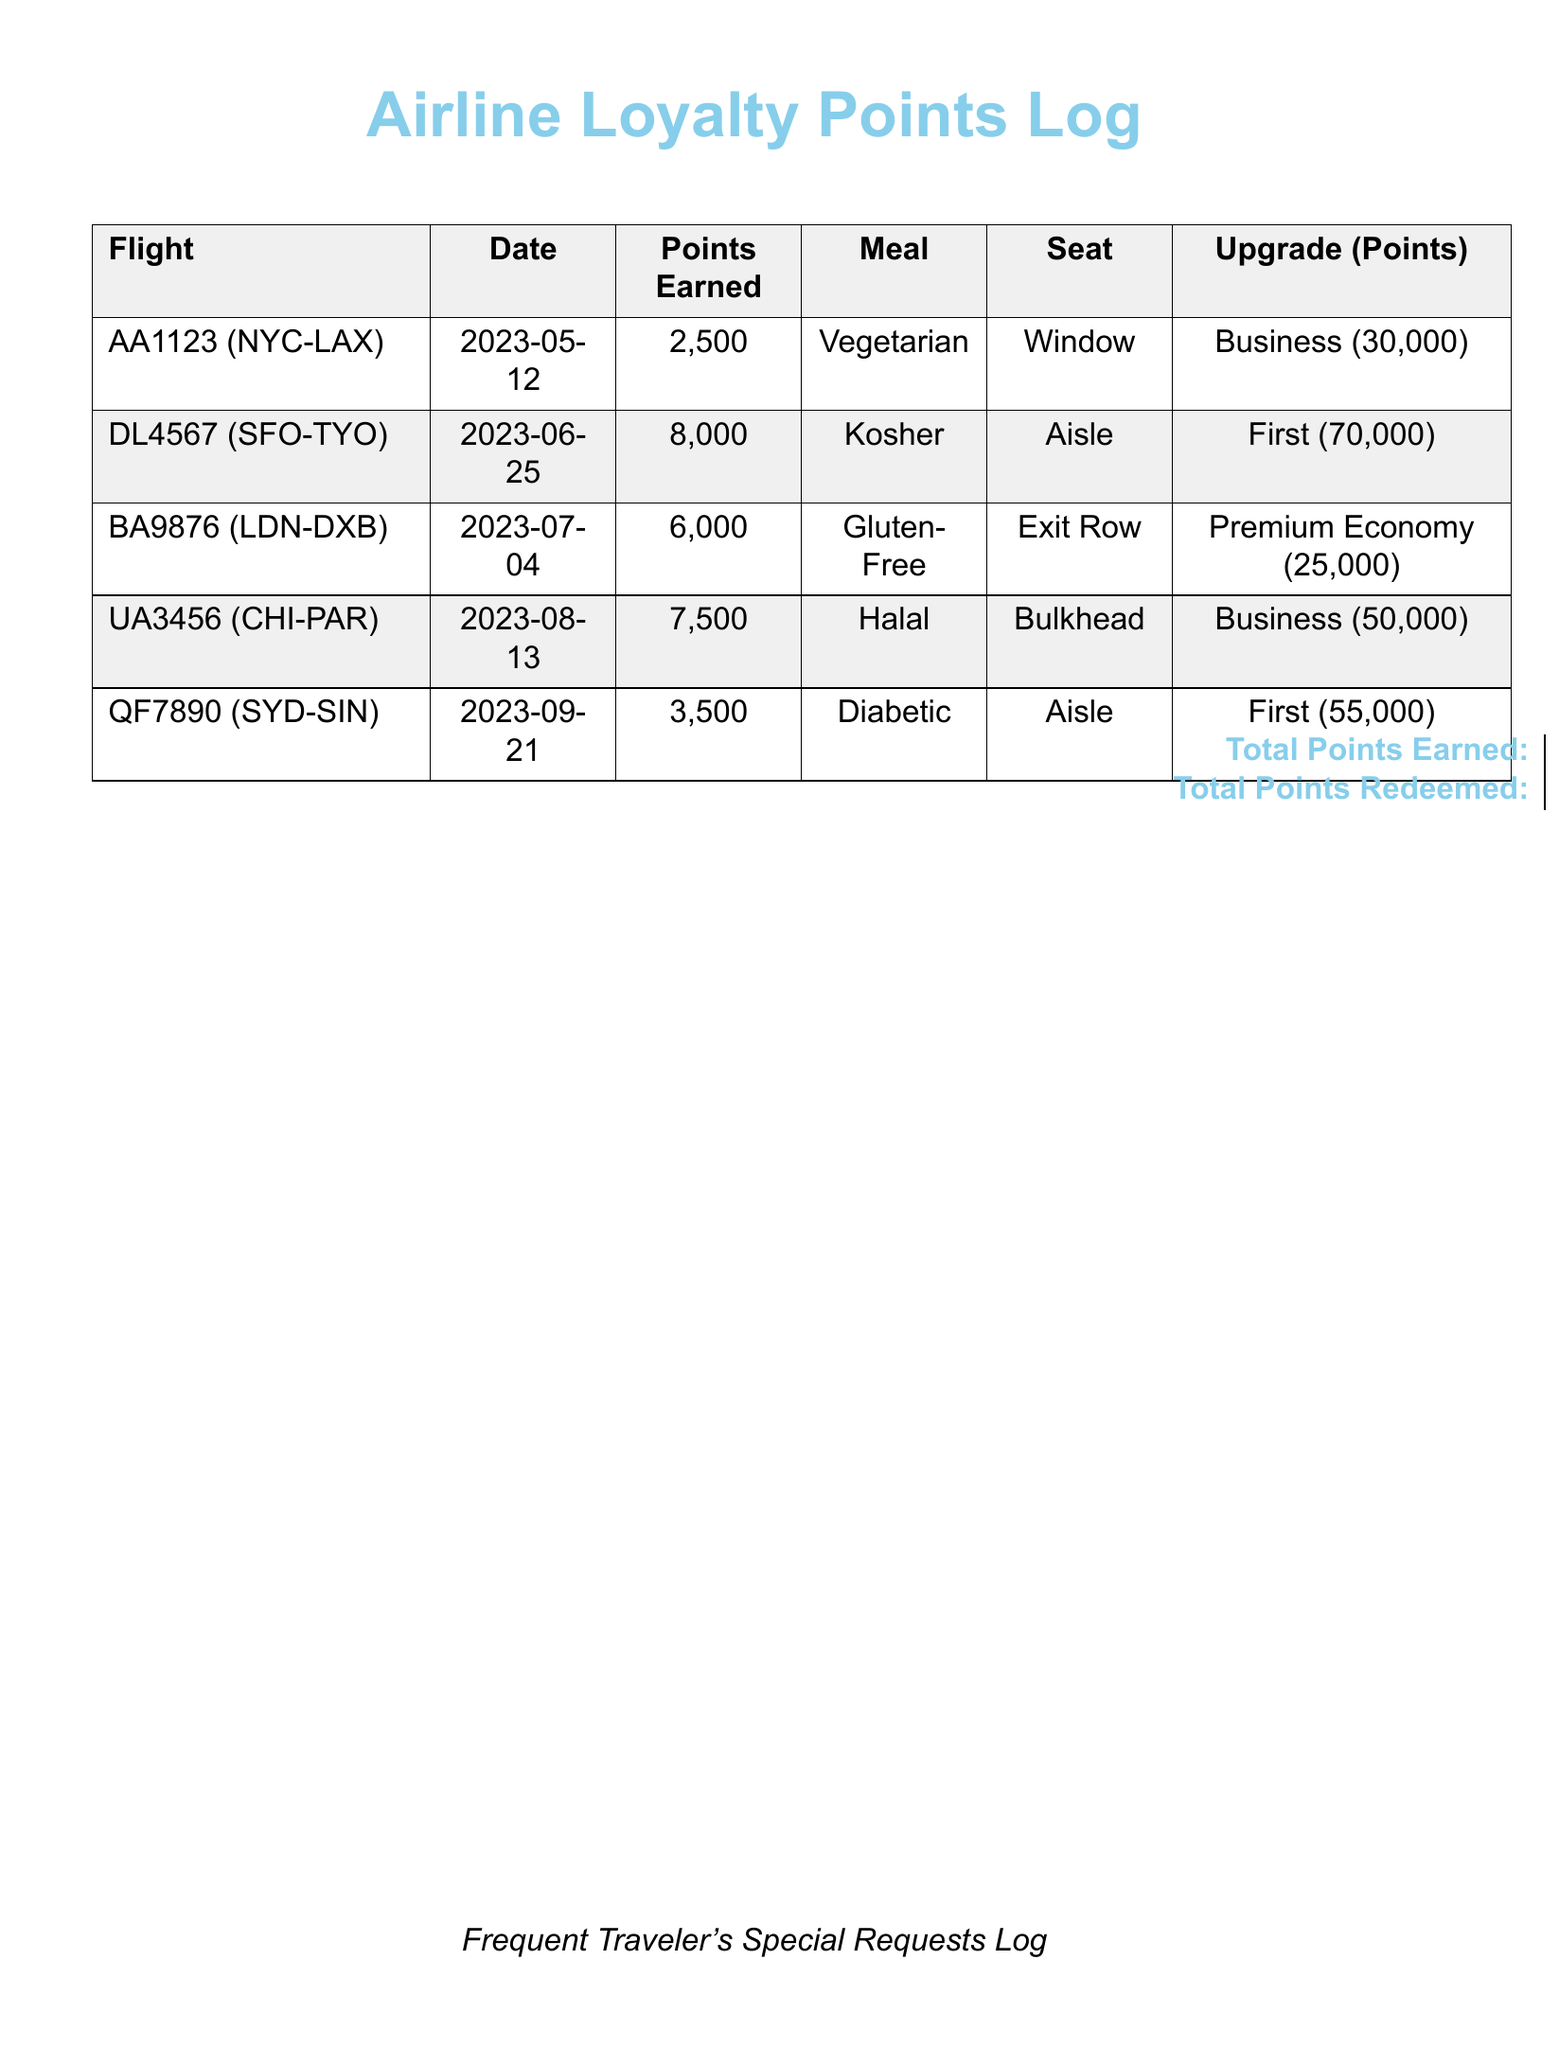What is the total points earned? The total points earned is summarized in the document, found in the footer.
Answer: 27,500 What type of meal was requested on flight AA1123? The meal type for each flight is specified in the meal column for every entry, including flight AA1123.
Answer: Vegetarian How many points were redeemed for the Business upgrade on flight UA3456? The points redeemed for upgrades are stated in the last column corresponding to the specific flight.
Answer: 50,000 What was the seating arrangement for flight DL4567? The seating arrangement is detailed in the seat column for flight DL4567.
Answer: Aisle Which flight had a Gluten-Free meal request? The meal type is noted for each flight, allowing us to identify the respective flight with a Gluten-Free meal.
Answer: BA9876 What is the total points redeemed? The total points redeemed is noted in the document's footer section.
Answer: 230,000 Which flight earned 8,000 points? The points earned for each flight are captured in the points earned column, identifying the flight with that specific amount.
Answer: DL4567 What is the date of the flight from Chicago to Paris? The date for each flight is provided in the document, enabling us to answer this question directly.
Answer: 2023-08-13 How many points were earned for the flight from Sydney to Singapore? This information is found in the points earned column for the flight from Sydney to Singapore.
Answer: 3,500 